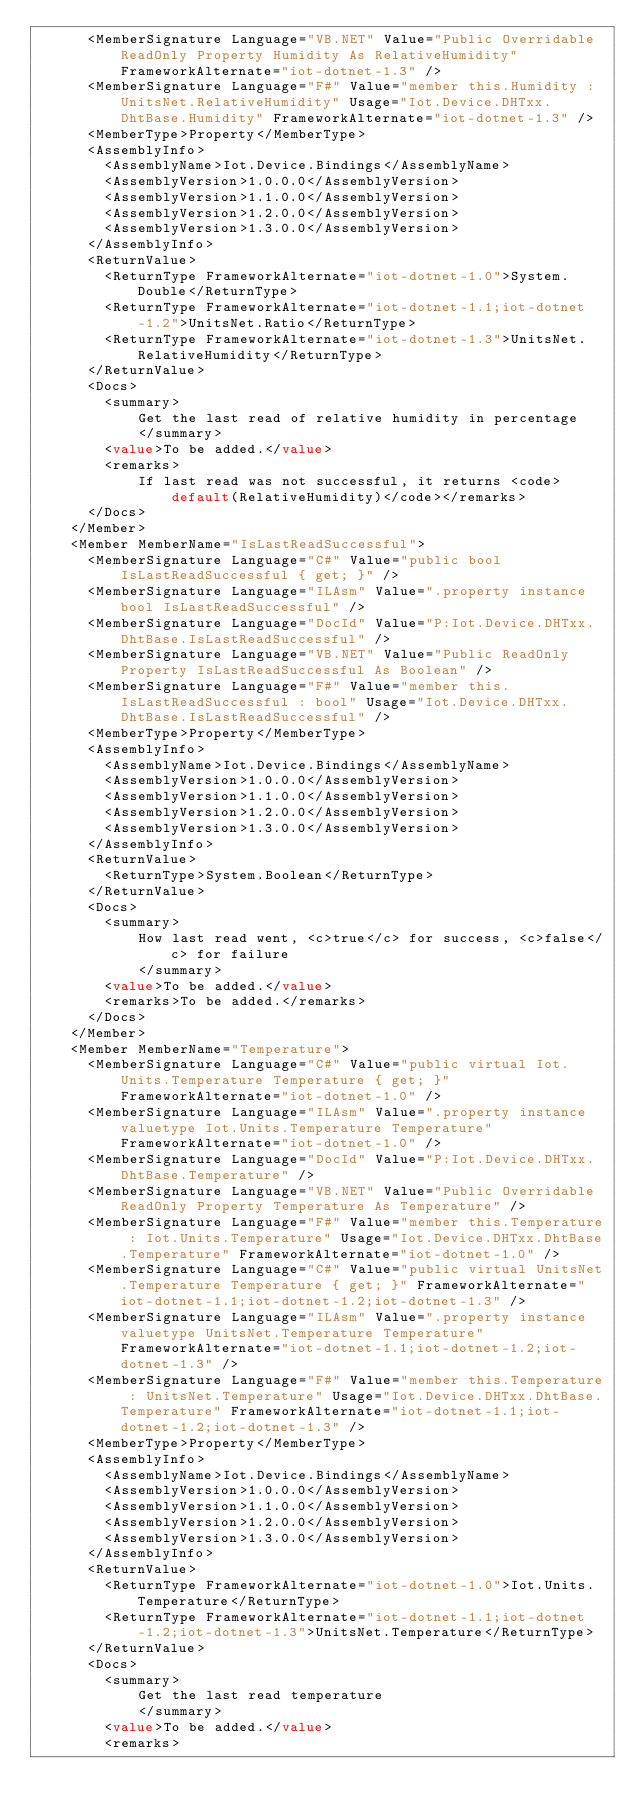<code> <loc_0><loc_0><loc_500><loc_500><_XML_>      <MemberSignature Language="VB.NET" Value="Public Overridable ReadOnly Property Humidity As RelativeHumidity" FrameworkAlternate="iot-dotnet-1.3" />
      <MemberSignature Language="F#" Value="member this.Humidity : UnitsNet.RelativeHumidity" Usage="Iot.Device.DHTxx.DhtBase.Humidity" FrameworkAlternate="iot-dotnet-1.3" />
      <MemberType>Property</MemberType>
      <AssemblyInfo>
        <AssemblyName>Iot.Device.Bindings</AssemblyName>
        <AssemblyVersion>1.0.0.0</AssemblyVersion>
        <AssemblyVersion>1.1.0.0</AssemblyVersion>
        <AssemblyVersion>1.2.0.0</AssemblyVersion>
        <AssemblyVersion>1.3.0.0</AssemblyVersion>
      </AssemblyInfo>
      <ReturnValue>
        <ReturnType FrameworkAlternate="iot-dotnet-1.0">System.Double</ReturnType>
        <ReturnType FrameworkAlternate="iot-dotnet-1.1;iot-dotnet-1.2">UnitsNet.Ratio</ReturnType>
        <ReturnType FrameworkAlternate="iot-dotnet-1.3">UnitsNet.RelativeHumidity</ReturnType>
      </ReturnValue>
      <Docs>
        <summary>
            Get the last read of relative humidity in percentage
            </summary>
        <value>To be added.</value>
        <remarks>
            If last read was not successful, it returns <code>default(RelativeHumidity)</code></remarks>
      </Docs>
    </Member>
    <Member MemberName="IsLastReadSuccessful">
      <MemberSignature Language="C#" Value="public bool IsLastReadSuccessful { get; }" />
      <MemberSignature Language="ILAsm" Value=".property instance bool IsLastReadSuccessful" />
      <MemberSignature Language="DocId" Value="P:Iot.Device.DHTxx.DhtBase.IsLastReadSuccessful" />
      <MemberSignature Language="VB.NET" Value="Public ReadOnly Property IsLastReadSuccessful As Boolean" />
      <MemberSignature Language="F#" Value="member this.IsLastReadSuccessful : bool" Usage="Iot.Device.DHTxx.DhtBase.IsLastReadSuccessful" />
      <MemberType>Property</MemberType>
      <AssemblyInfo>
        <AssemblyName>Iot.Device.Bindings</AssemblyName>
        <AssemblyVersion>1.0.0.0</AssemblyVersion>
        <AssemblyVersion>1.1.0.0</AssemblyVersion>
        <AssemblyVersion>1.2.0.0</AssemblyVersion>
        <AssemblyVersion>1.3.0.0</AssemblyVersion>
      </AssemblyInfo>
      <ReturnValue>
        <ReturnType>System.Boolean</ReturnType>
      </ReturnValue>
      <Docs>
        <summary>
            How last read went, <c>true</c> for success, <c>false</c> for failure
            </summary>
        <value>To be added.</value>
        <remarks>To be added.</remarks>
      </Docs>
    </Member>
    <Member MemberName="Temperature">
      <MemberSignature Language="C#" Value="public virtual Iot.Units.Temperature Temperature { get; }" FrameworkAlternate="iot-dotnet-1.0" />
      <MemberSignature Language="ILAsm" Value=".property instance valuetype Iot.Units.Temperature Temperature" FrameworkAlternate="iot-dotnet-1.0" />
      <MemberSignature Language="DocId" Value="P:Iot.Device.DHTxx.DhtBase.Temperature" />
      <MemberSignature Language="VB.NET" Value="Public Overridable ReadOnly Property Temperature As Temperature" />
      <MemberSignature Language="F#" Value="member this.Temperature : Iot.Units.Temperature" Usage="Iot.Device.DHTxx.DhtBase.Temperature" FrameworkAlternate="iot-dotnet-1.0" />
      <MemberSignature Language="C#" Value="public virtual UnitsNet.Temperature Temperature { get; }" FrameworkAlternate="iot-dotnet-1.1;iot-dotnet-1.2;iot-dotnet-1.3" />
      <MemberSignature Language="ILAsm" Value=".property instance valuetype UnitsNet.Temperature Temperature" FrameworkAlternate="iot-dotnet-1.1;iot-dotnet-1.2;iot-dotnet-1.3" />
      <MemberSignature Language="F#" Value="member this.Temperature : UnitsNet.Temperature" Usage="Iot.Device.DHTxx.DhtBase.Temperature" FrameworkAlternate="iot-dotnet-1.1;iot-dotnet-1.2;iot-dotnet-1.3" />
      <MemberType>Property</MemberType>
      <AssemblyInfo>
        <AssemblyName>Iot.Device.Bindings</AssemblyName>
        <AssemblyVersion>1.0.0.0</AssemblyVersion>
        <AssemblyVersion>1.1.0.0</AssemblyVersion>
        <AssemblyVersion>1.2.0.0</AssemblyVersion>
        <AssemblyVersion>1.3.0.0</AssemblyVersion>
      </AssemblyInfo>
      <ReturnValue>
        <ReturnType FrameworkAlternate="iot-dotnet-1.0">Iot.Units.Temperature</ReturnType>
        <ReturnType FrameworkAlternate="iot-dotnet-1.1;iot-dotnet-1.2;iot-dotnet-1.3">UnitsNet.Temperature</ReturnType>
      </ReturnValue>
      <Docs>
        <summary>
            Get the last read temperature
            </summary>
        <value>To be added.</value>
        <remarks></code> 